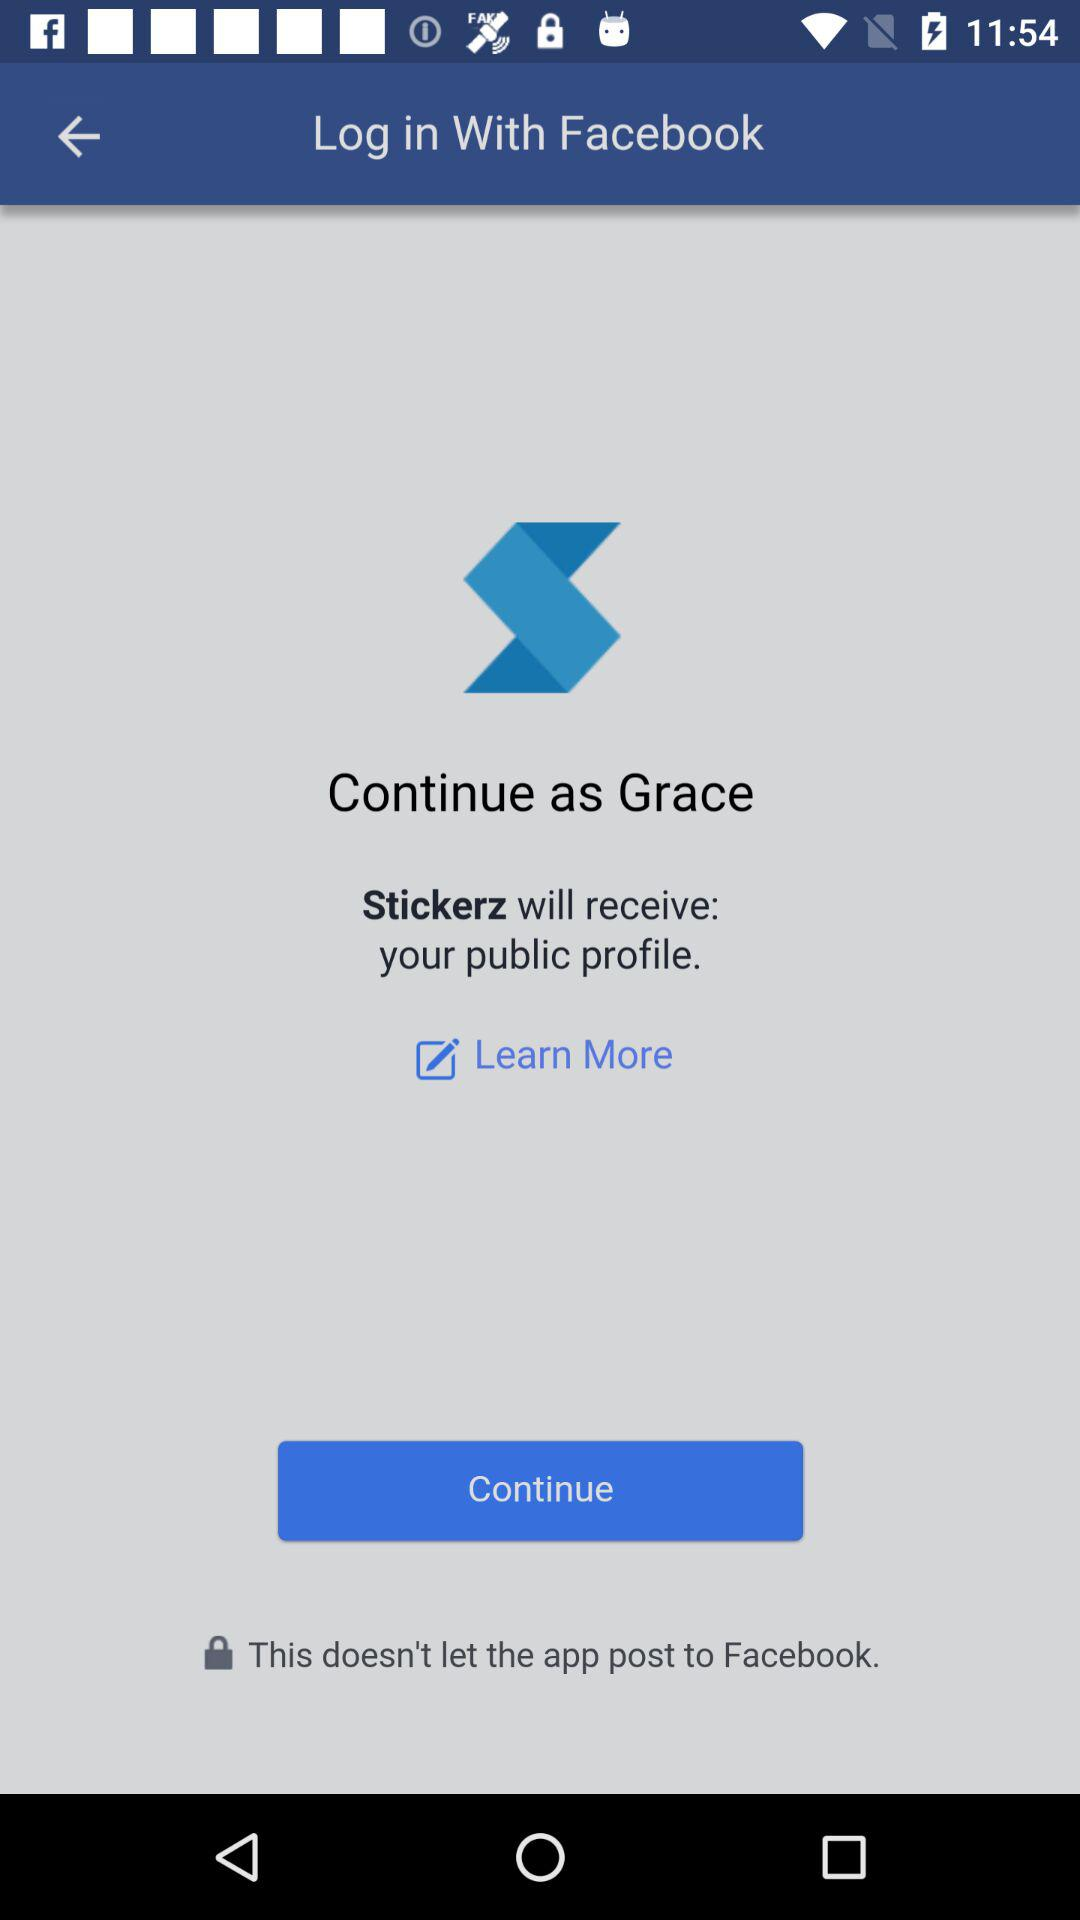What application will receive my public profile? The application that will receive your public profile is "Stickerz". 